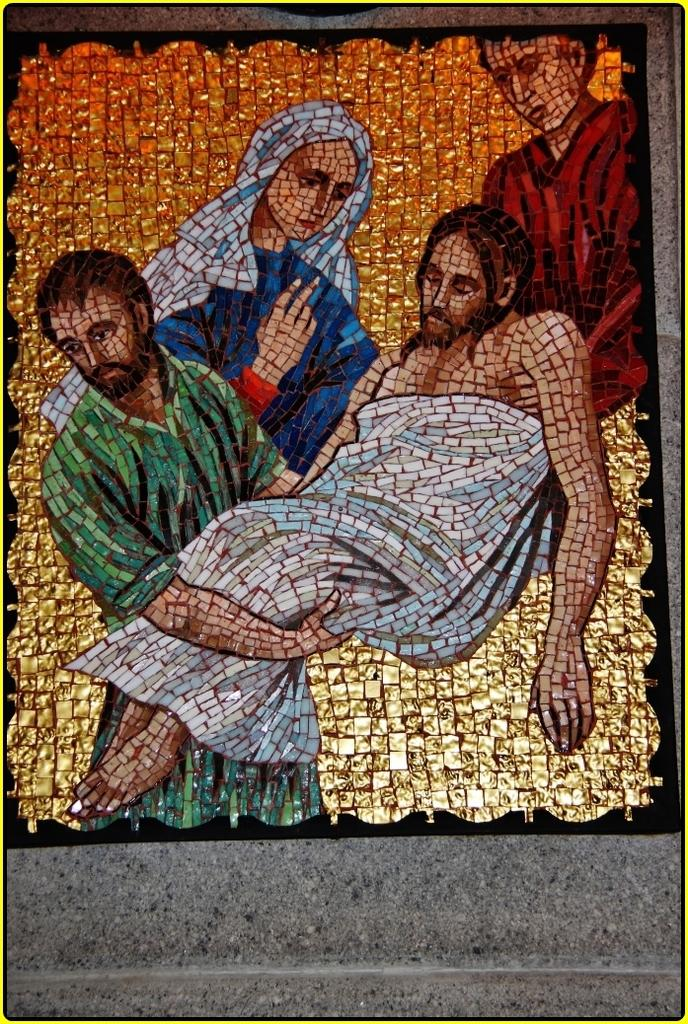What type of artwork is featured in the image? There is a glass painting in the image. What is the subject matter of the glass painting? The glass painting depicts people. How are the people in the painting represented? The people in the painting are made of marble pieces. Where is the glass painting located in the image? The glass painting is on a wall. Can you see any veils or crowns on the people in the glass painting? There is no mention of veils or crowns in the provided facts, so we cannot determine if they are present in the image. Are there any giants depicted in the glass painting? There is no mention of giants in the provided facts, so we cannot determine if they are present in the image. 